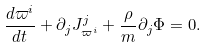Convert formula to latex. <formula><loc_0><loc_0><loc_500><loc_500>\frac { d \varpi ^ { i } } { d t } + \partial _ { j } J _ { \varpi ^ { i } } ^ { j } + \frac { \rho } { m } \partial _ { j } \Phi = 0 .</formula> 